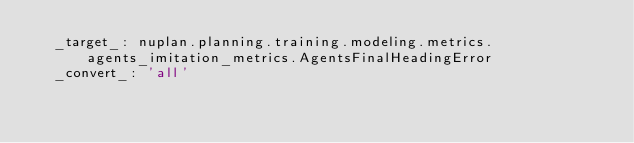Convert code to text. <code><loc_0><loc_0><loc_500><loc_500><_YAML_>  _target_: nuplan.planning.training.modeling.metrics.agents_imitation_metrics.AgentsFinalHeadingError
  _convert_: 'all'
</code> 